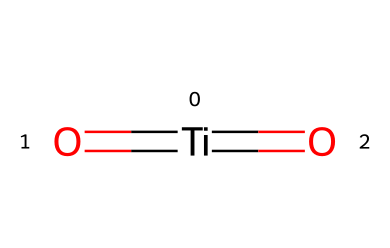What is the central metal in this compound? The central metal atom is titanium, which is indicated by the [Ti] in the SMILES representation.
Answer: titanium How many oxygen atoms are present? The SMILES structure shows two oxygen atoms attached to the titanium atom (two =O groups), so the total number is two.
Answer: two What type of bonds are formed between titanium and oxygen? The chemical structure indicates double bonds between titanium and each oxygen atom (denoted by the =O), resulting in two double bonds.
Answer: double bonds What is the primary use of this compound in sunscreens? Titanium dioxide primarily acts as a physical blocker that scatters and reflects UV radiation, providing skin protection from sun damage.
Answer: UV protection How does titanium dioxide contribute to skin protection mechanism? Titanium dioxide reflects and scatters ultraviolet light due to its high refractive index and can also absorb UV radiation, preventing it from penetrating the skin.
Answer: reflects and scatters UV light What makes titanium dioxide a preferred ingredient over chemical filters in sunscreens? Titanium dioxide is a physical sunscreen that creates a barrier on the skin, often resulting in less irritation compared to chemical UV filters.
Answer: less irritation What is the state of titanium dioxide in sunscreens? In sunscreens, titanium dioxide is commonly found in a fine particulate form or as nanoparticles, allowing for transparent application.
Answer: nanoparticles 